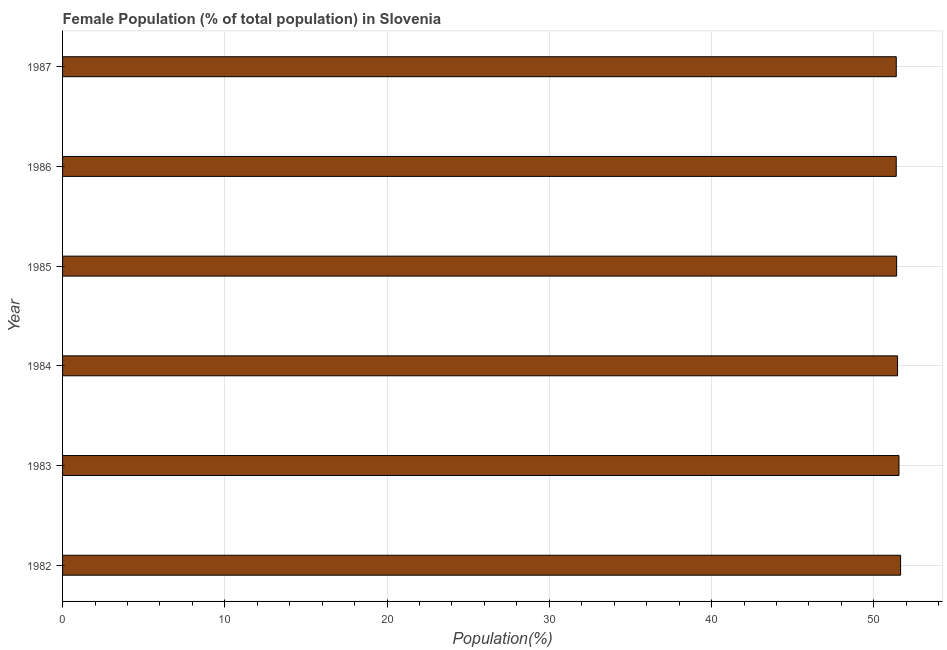What is the title of the graph?
Give a very brief answer. Female Population (% of total population) in Slovenia. What is the label or title of the X-axis?
Offer a terse response. Population(%). What is the female population in 1982?
Provide a short and direct response. 51.65. Across all years, what is the maximum female population?
Provide a succinct answer. 51.65. Across all years, what is the minimum female population?
Provide a short and direct response. 51.38. What is the sum of the female population?
Offer a very short reply. 308.84. What is the difference between the female population in 1986 and 1987?
Ensure brevity in your answer.  -0. What is the average female population per year?
Keep it short and to the point. 51.47. What is the median female population?
Give a very brief answer. 51.44. In how many years, is the female population greater than 28 %?
Your response must be concise. 6. What is the difference between the highest and the second highest female population?
Make the answer very short. 0.1. Is the sum of the female population in 1982 and 1984 greater than the maximum female population across all years?
Provide a short and direct response. Yes. What is the difference between the highest and the lowest female population?
Offer a very short reply. 0.27. How many years are there in the graph?
Offer a terse response. 6. What is the Population(%) of 1982?
Offer a terse response. 51.65. What is the Population(%) in 1983?
Offer a terse response. 51.55. What is the Population(%) in 1984?
Provide a short and direct response. 51.46. What is the Population(%) in 1985?
Provide a short and direct response. 51.41. What is the Population(%) in 1986?
Your answer should be compact. 51.38. What is the Population(%) of 1987?
Your answer should be compact. 51.38. What is the difference between the Population(%) in 1982 and 1983?
Your answer should be very brief. 0.1. What is the difference between the Population(%) in 1982 and 1984?
Your answer should be very brief. 0.19. What is the difference between the Population(%) in 1982 and 1985?
Give a very brief answer. 0.24. What is the difference between the Population(%) in 1982 and 1986?
Offer a very short reply. 0.27. What is the difference between the Population(%) in 1982 and 1987?
Offer a terse response. 0.27. What is the difference between the Population(%) in 1983 and 1984?
Your response must be concise. 0.09. What is the difference between the Population(%) in 1983 and 1985?
Offer a very short reply. 0.15. What is the difference between the Population(%) in 1983 and 1986?
Give a very brief answer. 0.17. What is the difference between the Population(%) in 1983 and 1987?
Offer a terse response. 0.17. What is the difference between the Population(%) in 1984 and 1985?
Provide a succinct answer. 0.06. What is the difference between the Population(%) in 1984 and 1986?
Provide a succinct answer. 0.08. What is the difference between the Population(%) in 1984 and 1987?
Your answer should be very brief. 0.08. What is the difference between the Population(%) in 1985 and 1986?
Give a very brief answer. 0.02. What is the difference between the Population(%) in 1985 and 1987?
Make the answer very short. 0.02. What is the difference between the Population(%) in 1986 and 1987?
Your answer should be compact. -0. What is the ratio of the Population(%) in 1982 to that in 1985?
Keep it short and to the point. 1. What is the ratio of the Population(%) in 1983 to that in 1985?
Your answer should be very brief. 1. What is the ratio of the Population(%) in 1983 to that in 1986?
Offer a very short reply. 1. What is the ratio of the Population(%) in 1984 to that in 1986?
Your response must be concise. 1. What is the ratio of the Population(%) in 1984 to that in 1987?
Ensure brevity in your answer.  1. What is the ratio of the Population(%) in 1985 to that in 1987?
Offer a terse response. 1. What is the ratio of the Population(%) in 1986 to that in 1987?
Ensure brevity in your answer.  1. 